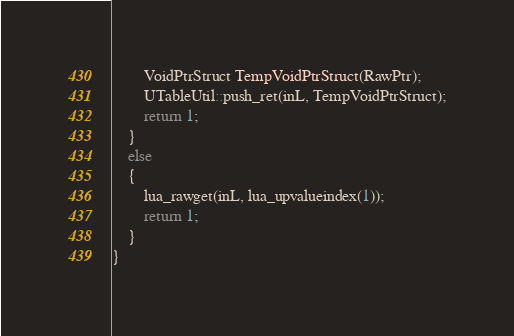Convert code to text. <code><loc_0><loc_0><loc_500><loc_500><_C++_>		VoidPtrStruct TempVoidPtrStruct(RawPtr);
		UTableUtil::push_ret(inL, TempVoidPtrStruct);
		return 1;
	}
	else
	{
		lua_rawget(inL, lua_upvalueindex(1)); 
		return 1;
	}
}
</code> 